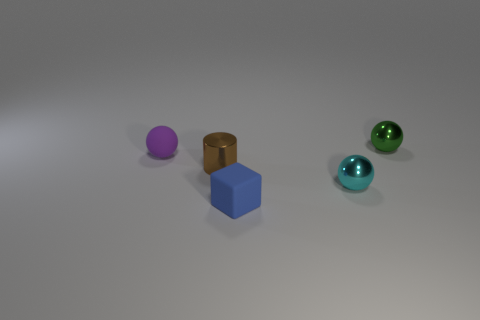Add 1 large cyan matte balls. How many objects exist? 6 Subtract all cubes. How many objects are left? 4 Subtract 0 yellow cubes. How many objects are left? 5 Subtract all green things. Subtract all green matte cubes. How many objects are left? 4 Add 4 cyan objects. How many cyan objects are left? 5 Add 4 tiny blue blocks. How many tiny blue blocks exist? 5 